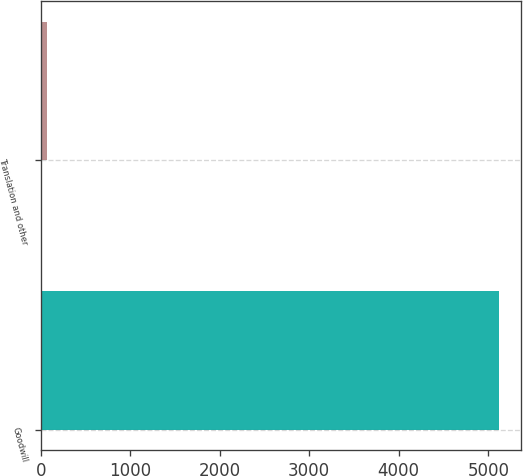Convert chart. <chart><loc_0><loc_0><loc_500><loc_500><bar_chart><fcel>Goodwill<fcel>Translation and other<nl><fcel>5115<fcel>73<nl></chart> 